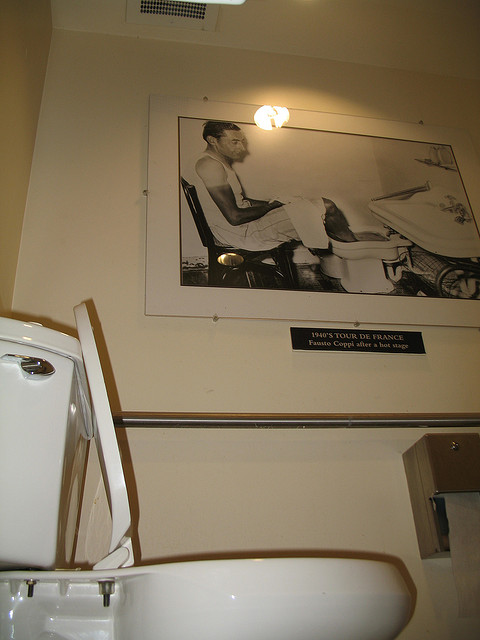Identify and read out the text in this image. 1940's Fiurto stage tour FRANCE a after Coppy DE 